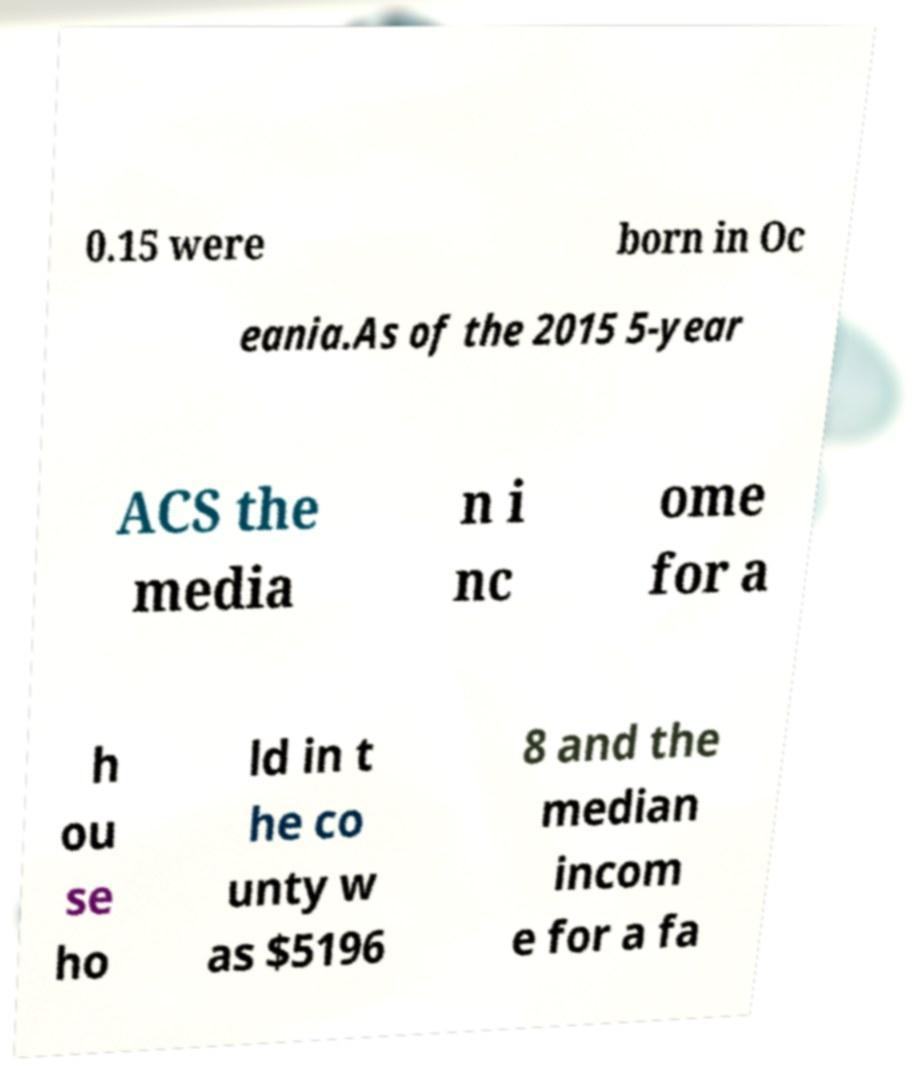For documentation purposes, I need the text within this image transcribed. Could you provide that? 0.15 were born in Oc eania.As of the 2015 5-year ACS the media n i nc ome for a h ou se ho ld in t he co unty w as $5196 8 and the median incom e for a fa 